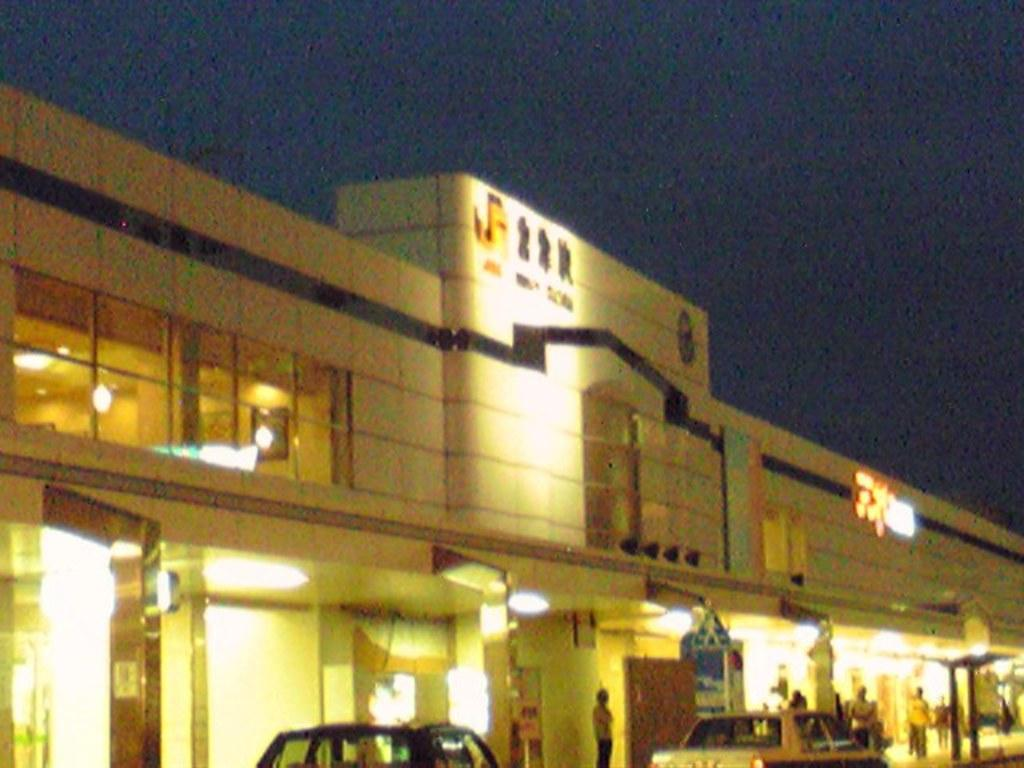What is the main subject in the center of the image? There is a building in the center of the image. Are there any living beings present in the image? Yes, there are people in the image. What else can be seen in the image besides the building and people? There are vehicles, lights, a pillar, text, and other objects in the image. What is visible at the top of the image? The sky is visible at the top of the image. What type of scent can be detected coming from the scarecrow in the image? There is no scarecrow present in the image, so it is not possible to determine what scent might be associated with it. 